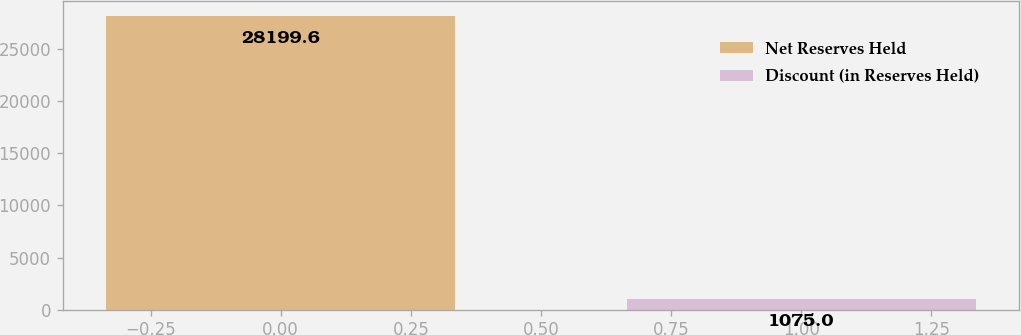Convert chart to OTSL. <chart><loc_0><loc_0><loc_500><loc_500><bar_chart><fcel>Net Reserves Held<fcel>Discount (in Reserves Held)<nl><fcel>28199.6<fcel>1075<nl></chart> 